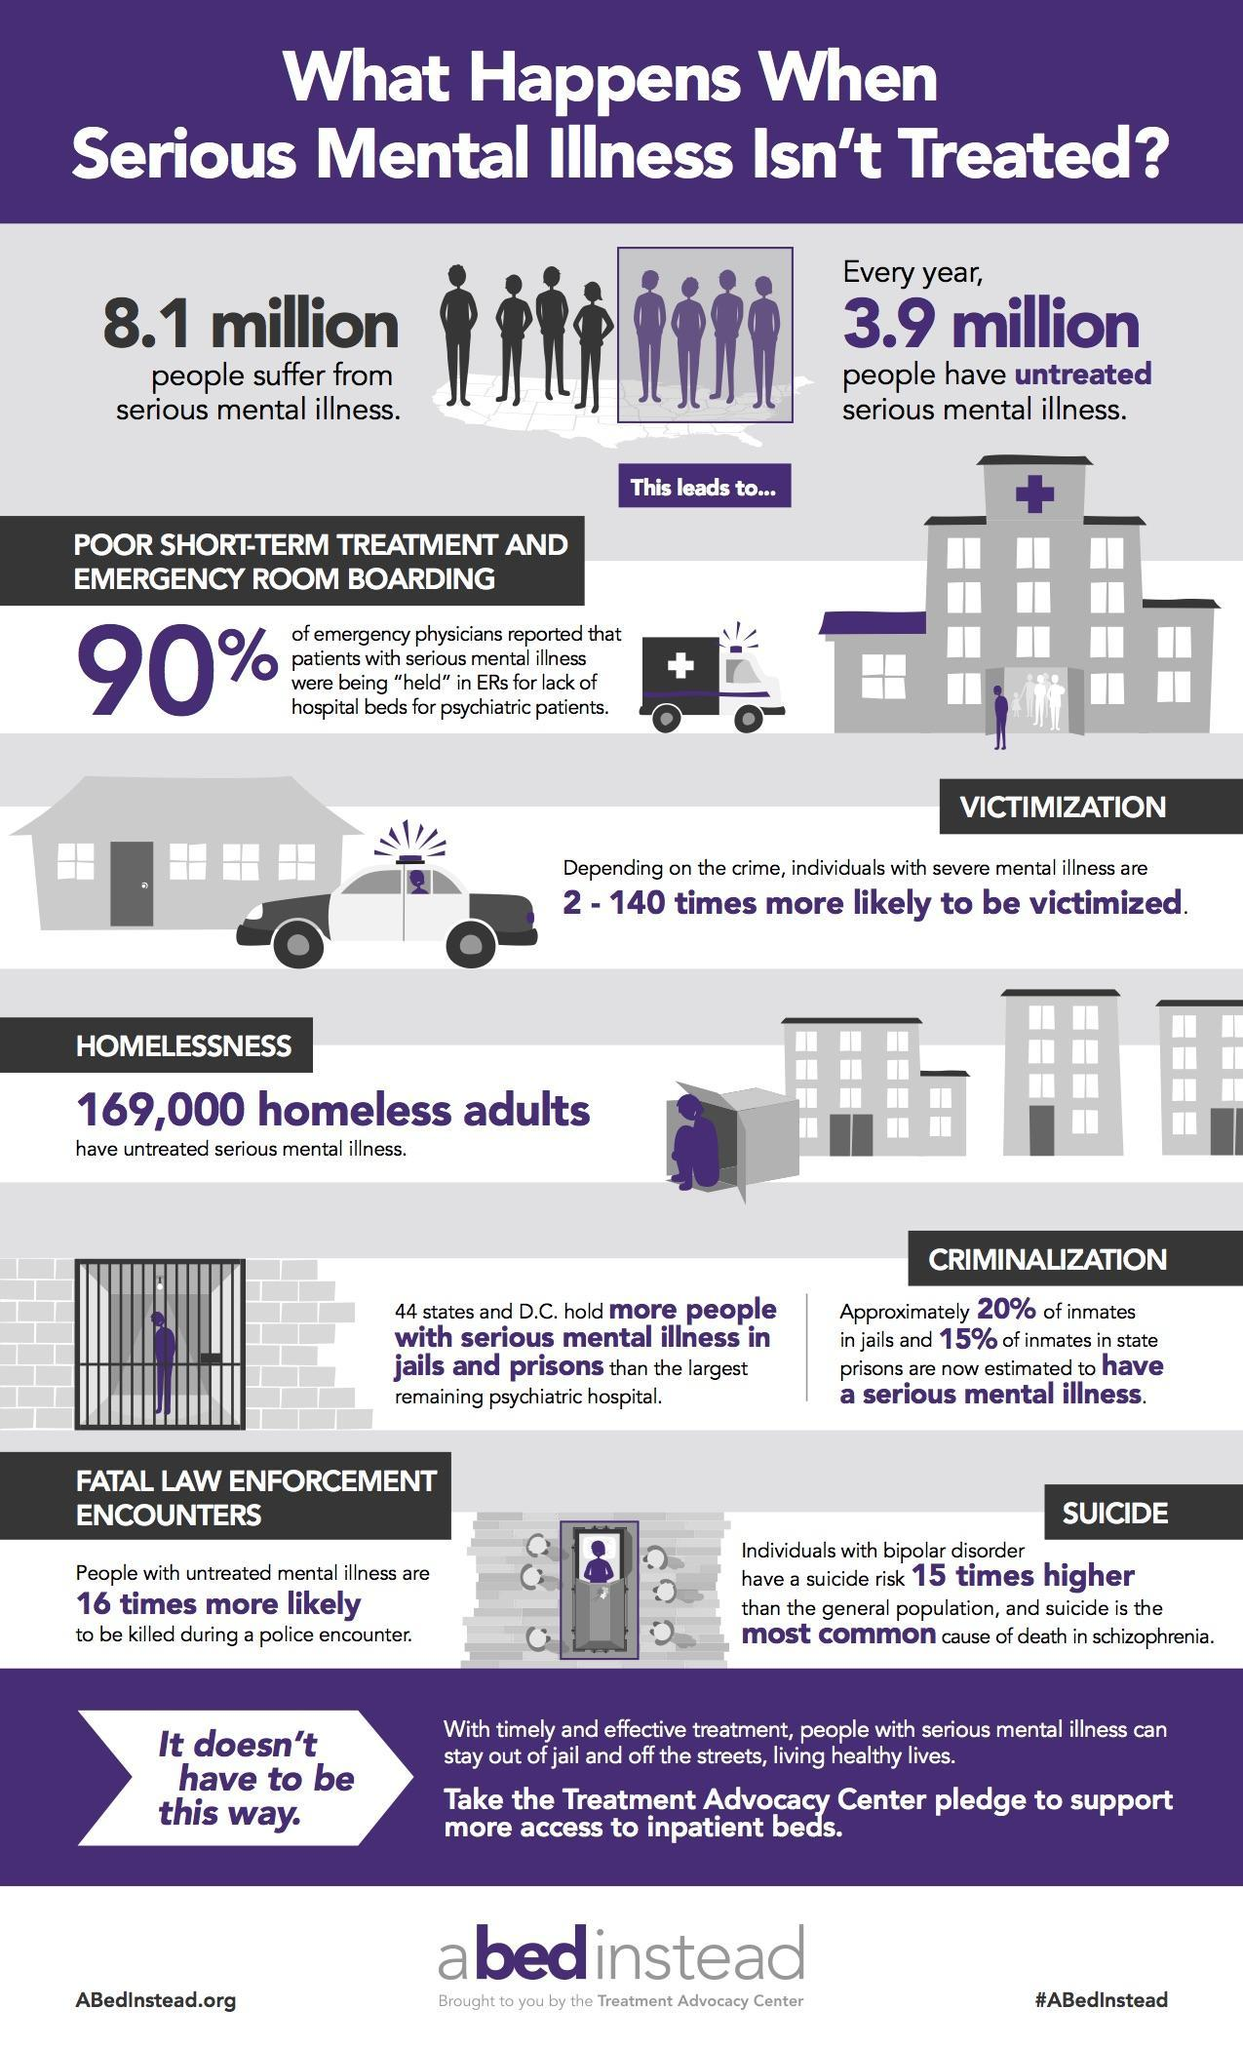what is the most common cause of death in schizophrenia
Answer the question with a short phrase. suicide how many suffer from serious mental illness 8.1 million how much higher is the fatal law enforcement encouters for mentally ill 16 times compared to psychiatric hospital where are more people with serious mental illness held jails and prisons how many have untreated serious mental illness 3.9 million 